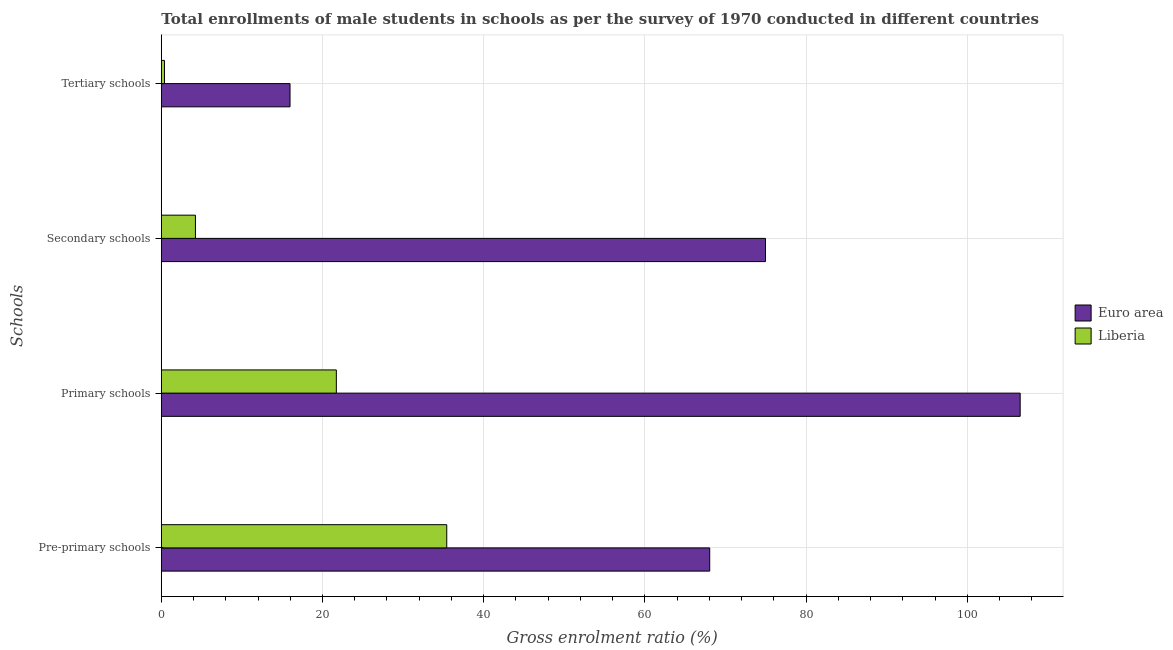How many different coloured bars are there?
Provide a succinct answer. 2. How many groups of bars are there?
Offer a very short reply. 4. Are the number of bars per tick equal to the number of legend labels?
Your answer should be very brief. Yes. How many bars are there on the 3rd tick from the top?
Offer a terse response. 2. What is the label of the 3rd group of bars from the top?
Provide a short and direct response. Primary schools. What is the gross enrolment ratio(male) in secondary schools in Liberia?
Provide a short and direct response. 4.23. Across all countries, what is the maximum gross enrolment ratio(male) in tertiary schools?
Your answer should be very brief. 15.97. Across all countries, what is the minimum gross enrolment ratio(male) in secondary schools?
Ensure brevity in your answer.  4.23. In which country was the gross enrolment ratio(male) in primary schools maximum?
Give a very brief answer. Euro area. In which country was the gross enrolment ratio(male) in tertiary schools minimum?
Offer a terse response. Liberia. What is the total gross enrolment ratio(male) in primary schools in the graph?
Offer a very short reply. 128.28. What is the difference between the gross enrolment ratio(male) in tertiary schools in Liberia and that in Euro area?
Give a very brief answer. -15.57. What is the difference between the gross enrolment ratio(male) in primary schools in Euro area and the gross enrolment ratio(male) in tertiary schools in Liberia?
Offer a very short reply. 106.17. What is the average gross enrolment ratio(male) in primary schools per country?
Keep it short and to the point. 64.14. What is the difference between the gross enrolment ratio(male) in primary schools and gross enrolment ratio(male) in secondary schools in Liberia?
Provide a short and direct response. 17.48. In how many countries, is the gross enrolment ratio(male) in pre-primary schools greater than 16 %?
Ensure brevity in your answer.  2. What is the ratio of the gross enrolment ratio(male) in pre-primary schools in Euro area to that in Liberia?
Keep it short and to the point. 1.92. What is the difference between the highest and the second highest gross enrolment ratio(male) in tertiary schools?
Offer a very short reply. 15.57. What is the difference between the highest and the lowest gross enrolment ratio(male) in primary schools?
Your answer should be compact. 84.85. Is the sum of the gross enrolment ratio(male) in secondary schools in Euro area and Liberia greater than the maximum gross enrolment ratio(male) in tertiary schools across all countries?
Make the answer very short. Yes. Is it the case that in every country, the sum of the gross enrolment ratio(male) in secondary schools and gross enrolment ratio(male) in primary schools is greater than the sum of gross enrolment ratio(male) in tertiary schools and gross enrolment ratio(male) in pre-primary schools?
Your response must be concise. No. What does the 1st bar from the top in Tertiary schools represents?
Offer a terse response. Liberia. How many bars are there?
Ensure brevity in your answer.  8. Are all the bars in the graph horizontal?
Offer a very short reply. Yes. How many countries are there in the graph?
Your response must be concise. 2. What is the difference between two consecutive major ticks on the X-axis?
Ensure brevity in your answer.  20. Are the values on the major ticks of X-axis written in scientific E-notation?
Make the answer very short. No. Does the graph contain grids?
Make the answer very short. Yes. Where does the legend appear in the graph?
Your answer should be compact. Center right. What is the title of the graph?
Offer a terse response. Total enrollments of male students in schools as per the survey of 1970 conducted in different countries. Does "Latin America(all income levels)" appear as one of the legend labels in the graph?
Ensure brevity in your answer.  No. What is the label or title of the Y-axis?
Provide a succinct answer. Schools. What is the Gross enrolment ratio (%) of Euro area in Pre-primary schools?
Ensure brevity in your answer.  68.04. What is the Gross enrolment ratio (%) in Liberia in Pre-primary schools?
Provide a succinct answer. 35.42. What is the Gross enrolment ratio (%) in Euro area in Primary schools?
Ensure brevity in your answer.  106.56. What is the Gross enrolment ratio (%) in Liberia in Primary schools?
Offer a very short reply. 21.72. What is the Gross enrolment ratio (%) of Euro area in Secondary schools?
Ensure brevity in your answer.  74.96. What is the Gross enrolment ratio (%) of Liberia in Secondary schools?
Offer a very short reply. 4.23. What is the Gross enrolment ratio (%) of Euro area in Tertiary schools?
Keep it short and to the point. 15.97. What is the Gross enrolment ratio (%) of Liberia in Tertiary schools?
Provide a short and direct response. 0.4. Across all Schools, what is the maximum Gross enrolment ratio (%) in Euro area?
Offer a terse response. 106.56. Across all Schools, what is the maximum Gross enrolment ratio (%) of Liberia?
Your answer should be very brief. 35.42. Across all Schools, what is the minimum Gross enrolment ratio (%) of Euro area?
Your answer should be compact. 15.97. Across all Schools, what is the minimum Gross enrolment ratio (%) of Liberia?
Provide a short and direct response. 0.4. What is the total Gross enrolment ratio (%) of Euro area in the graph?
Offer a terse response. 265.54. What is the total Gross enrolment ratio (%) in Liberia in the graph?
Provide a succinct answer. 61.76. What is the difference between the Gross enrolment ratio (%) of Euro area in Pre-primary schools and that in Primary schools?
Provide a short and direct response. -38.52. What is the difference between the Gross enrolment ratio (%) in Liberia in Pre-primary schools and that in Primary schools?
Give a very brief answer. 13.7. What is the difference between the Gross enrolment ratio (%) in Euro area in Pre-primary schools and that in Secondary schools?
Make the answer very short. -6.92. What is the difference between the Gross enrolment ratio (%) of Liberia in Pre-primary schools and that in Secondary schools?
Your answer should be very brief. 31.18. What is the difference between the Gross enrolment ratio (%) of Euro area in Pre-primary schools and that in Tertiary schools?
Your answer should be compact. 52.07. What is the difference between the Gross enrolment ratio (%) of Liberia in Pre-primary schools and that in Tertiary schools?
Make the answer very short. 35.02. What is the difference between the Gross enrolment ratio (%) in Euro area in Primary schools and that in Secondary schools?
Offer a terse response. 31.6. What is the difference between the Gross enrolment ratio (%) of Liberia in Primary schools and that in Secondary schools?
Offer a very short reply. 17.48. What is the difference between the Gross enrolment ratio (%) in Euro area in Primary schools and that in Tertiary schools?
Your answer should be compact. 90.59. What is the difference between the Gross enrolment ratio (%) in Liberia in Primary schools and that in Tertiary schools?
Your answer should be very brief. 21.32. What is the difference between the Gross enrolment ratio (%) of Euro area in Secondary schools and that in Tertiary schools?
Provide a succinct answer. 58.99. What is the difference between the Gross enrolment ratio (%) in Liberia in Secondary schools and that in Tertiary schools?
Provide a short and direct response. 3.84. What is the difference between the Gross enrolment ratio (%) in Euro area in Pre-primary schools and the Gross enrolment ratio (%) in Liberia in Primary schools?
Give a very brief answer. 46.33. What is the difference between the Gross enrolment ratio (%) of Euro area in Pre-primary schools and the Gross enrolment ratio (%) of Liberia in Secondary schools?
Ensure brevity in your answer.  63.81. What is the difference between the Gross enrolment ratio (%) in Euro area in Pre-primary schools and the Gross enrolment ratio (%) in Liberia in Tertiary schools?
Keep it short and to the point. 67.65. What is the difference between the Gross enrolment ratio (%) of Euro area in Primary schools and the Gross enrolment ratio (%) of Liberia in Secondary schools?
Offer a very short reply. 102.33. What is the difference between the Gross enrolment ratio (%) of Euro area in Primary schools and the Gross enrolment ratio (%) of Liberia in Tertiary schools?
Give a very brief answer. 106.17. What is the difference between the Gross enrolment ratio (%) of Euro area in Secondary schools and the Gross enrolment ratio (%) of Liberia in Tertiary schools?
Give a very brief answer. 74.57. What is the average Gross enrolment ratio (%) of Euro area per Schools?
Keep it short and to the point. 66.39. What is the average Gross enrolment ratio (%) of Liberia per Schools?
Make the answer very short. 15.44. What is the difference between the Gross enrolment ratio (%) in Euro area and Gross enrolment ratio (%) in Liberia in Pre-primary schools?
Offer a terse response. 32.63. What is the difference between the Gross enrolment ratio (%) in Euro area and Gross enrolment ratio (%) in Liberia in Primary schools?
Provide a short and direct response. 84.85. What is the difference between the Gross enrolment ratio (%) of Euro area and Gross enrolment ratio (%) of Liberia in Secondary schools?
Provide a succinct answer. 70.73. What is the difference between the Gross enrolment ratio (%) in Euro area and Gross enrolment ratio (%) in Liberia in Tertiary schools?
Provide a short and direct response. 15.57. What is the ratio of the Gross enrolment ratio (%) in Euro area in Pre-primary schools to that in Primary schools?
Offer a terse response. 0.64. What is the ratio of the Gross enrolment ratio (%) of Liberia in Pre-primary schools to that in Primary schools?
Provide a succinct answer. 1.63. What is the ratio of the Gross enrolment ratio (%) in Euro area in Pre-primary schools to that in Secondary schools?
Make the answer very short. 0.91. What is the ratio of the Gross enrolment ratio (%) of Liberia in Pre-primary schools to that in Secondary schools?
Offer a terse response. 8.37. What is the ratio of the Gross enrolment ratio (%) in Euro area in Pre-primary schools to that in Tertiary schools?
Keep it short and to the point. 4.26. What is the ratio of the Gross enrolment ratio (%) in Liberia in Pre-primary schools to that in Tertiary schools?
Provide a short and direct response. 89.24. What is the ratio of the Gross enrolment ratio (%) in Euro area in Primary schools to that in Secondary schools?
Offer a terse response. 1.42. What is the ratio of the Gross enrolment ratio (%) of Liberia in Primary schools to that in Secondary schools?
Make the answer very short. 5.13. What is the ratio of the Gross enrolment ratio (%) in Euro area in Primary schools to that in Tertiary schools?
Make the answer very short. 6.67. What is the ratio of the Gross enrolment ratio (%) of Liberia in Primary schools to that in Tertiary schools?
Offer a terse response. 54.72. What is the ratio of the Gross enrolment ratio (%) of Euro area in Secondary schools to that in Tertiary schools?
Your answer should be compact. 4.69. What is the ratio of the Gross enrolment ratio (%) of Liberia in Secondary schools to that in Tertiary schools?
Your answer should be compact. 10.67. What is the difference between the highest and the second highest Gross enrolment ratio (%) in Euro area?
Your response must be concise. 31.6. What is the difference between the highest and the second highest Gross enrolment ratio (%) of Liberia?
Make the answer very short. 13.7. What is the difference between the highest and the lowest Gross enrolment ratio (%) of Euro area?
Offer a terse response. 90.59. What is the difference between the highest and the lowest Gross enrolment ratio (%) in Liberia?
Give a very brief answer. 35.02. 